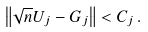<formula> <loc_0><loc_0><loc_500><loc_500>\left \| \sqrt { n } U _ { j } - G _ { j } \right \| < C _ { j } \, .</formula> 